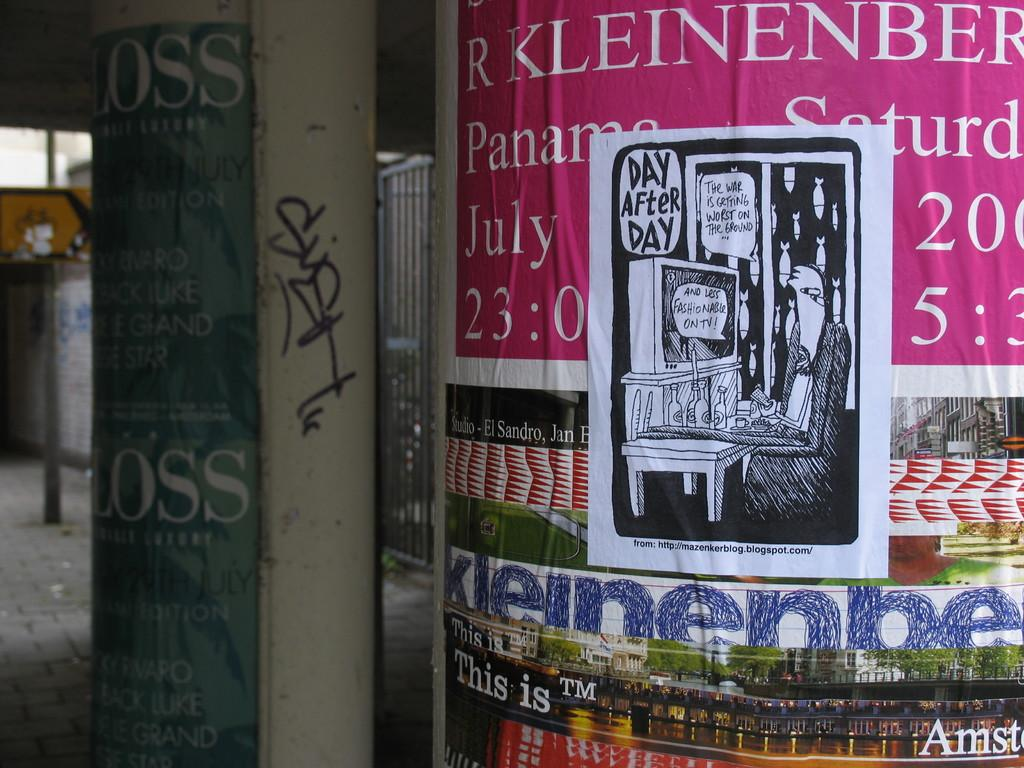What is located in the center of the image? There are pillars with posters in the center of the image. What can be seen in the background of the image? There is a sign board in the background of the image. How many seeds are planted near the pillars in the image? There is no mention of seeds or any planting activity in the image. Can you describe the type of plough used by the visitor in the image? There is no visitor or plough present in the image. 